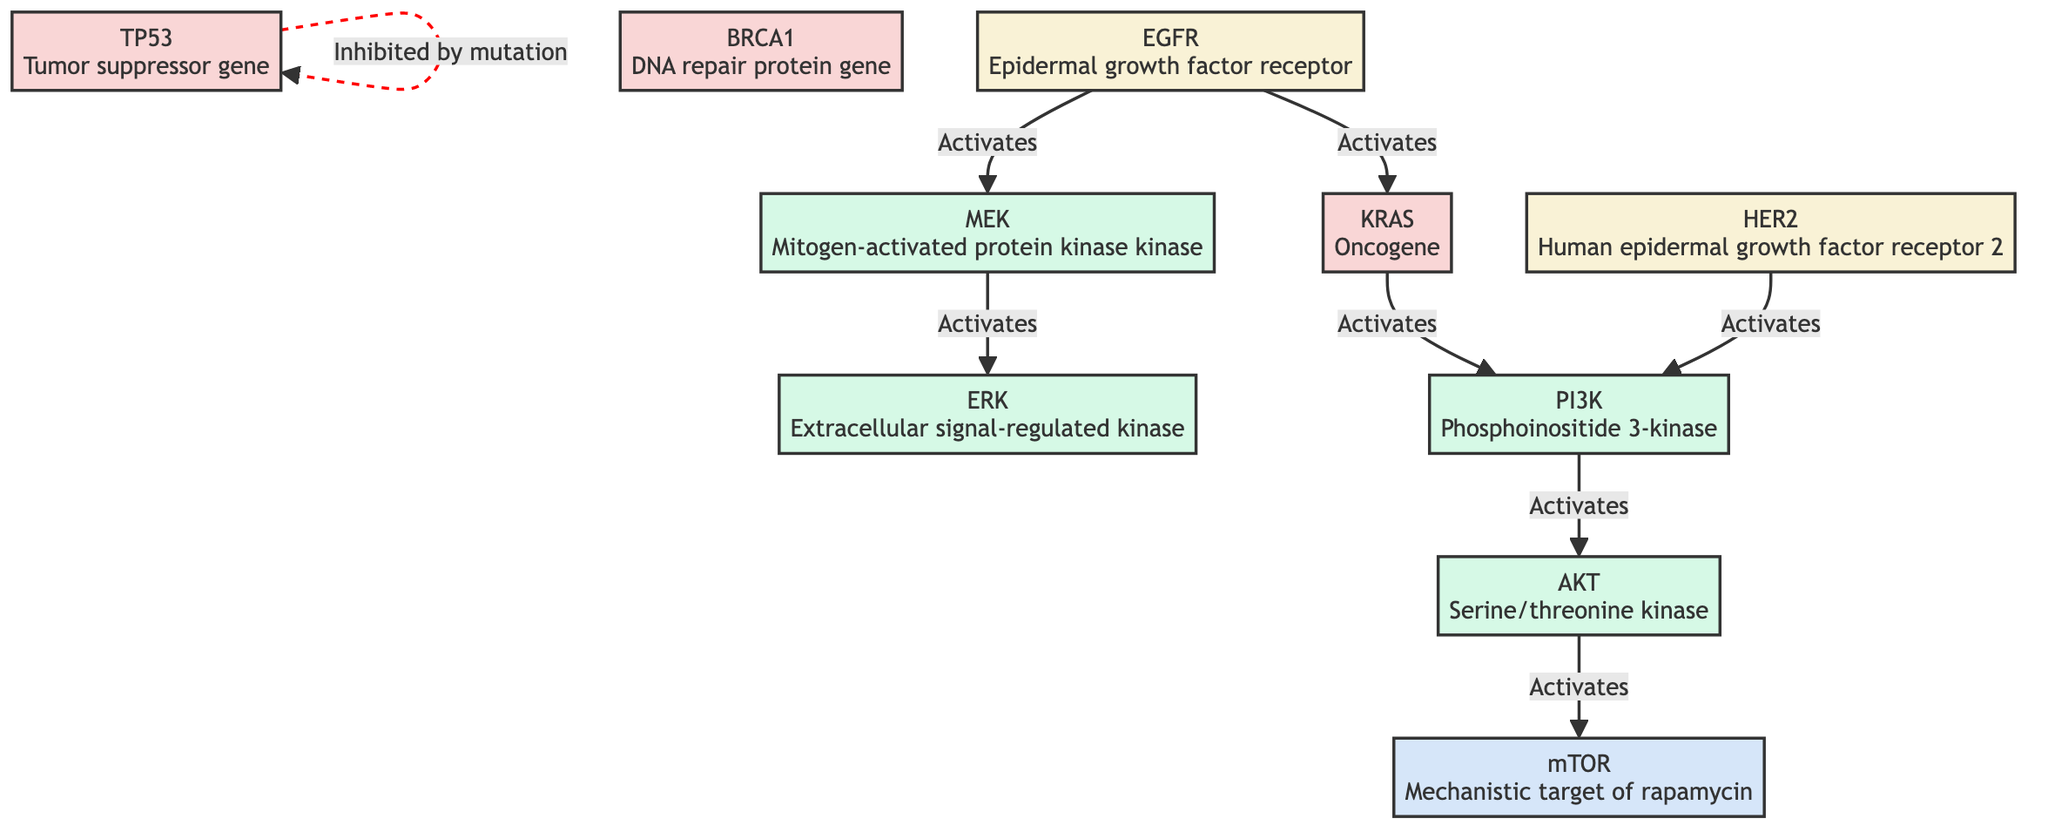What is the function of TP53 in the diagram? TP53 is indicated as a tumor suppressor gene, which means it plays a crucial role in regulating cell division and preventing tumor formation.
Answer: Tumor suppressor gene How many genes are represented in the diagram? The diagram includes three genes: TP53, BRCA1, and KRAS. Therefore, the total count is determined by identifying the node types labeled as genes.
Answer: Three Which protein is activated by AKT? The diagram shows that AKT activates the mTOR protein, indicating a direct interaction in the pathway for cell growth and metabolism.
Answer: mTOR What type of interaction is shown between TP53 and TP53 in the diagram? The interaction is represented as a dashed line, indicating that TP53 is inhibited by mutation, which suggests its normal functioning is compromised by genetic alterations.
Answer: Inhibited by mutation Which two receptors activate PI3K according to the diagram? The diagram shows that both EGFR and HER2 activate PI3K, highlighting their critical roles in signaling pathways that contribute to cell proliferation and survival.
Answer: EGFR and HER2 How many types of interactions are depicted in the diagram? The diagram outlines two types of interactions; solid lines for activation and a dashed line for inhibition, reflecting the varied molecular interactions in the genetic pathways.
Answer: Two types What is the role of KRAS in the signaling pathway? KRAS acts as an oncogene that, upon activation by EGFR, further activates PI3K, indicating its function as a key mediator in promoting cell growth and survival.
Answer: Oncogene Which protein is directly activated by MEK? MEK activates ERK, establishing a signaling cascade that is critical for cellular responses such as growth and differentiation, as shown in the connections of the diagram.
Answer: ERK What type of pathway does this diagram illustrate? The diagram illustrates genetic pathways involved in disease, specifically focusing on the interactions of genes and proteins that are relevant to the development of diseases like cancer.
Answer: Genetic pathways in disease 